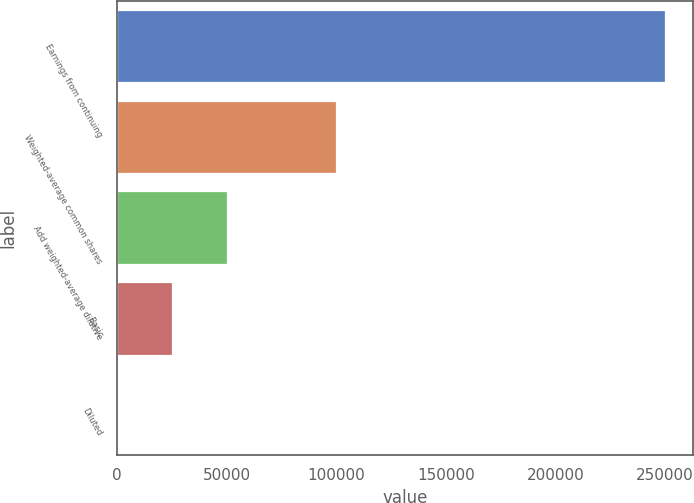Convert chart. <chart><loc_0><loc_0><loc_500><loc_500><bar_chart><fcel>Earnings from continuing<fcel>Weighted-average common shares<fcel>Add weighted-average dilutive<fcel>Basic<fcel>Diluted<nl><fcel>250258<fcel>100105<fcel>50054.5<fcel>25029<fcel>3.61<nl></chart> 